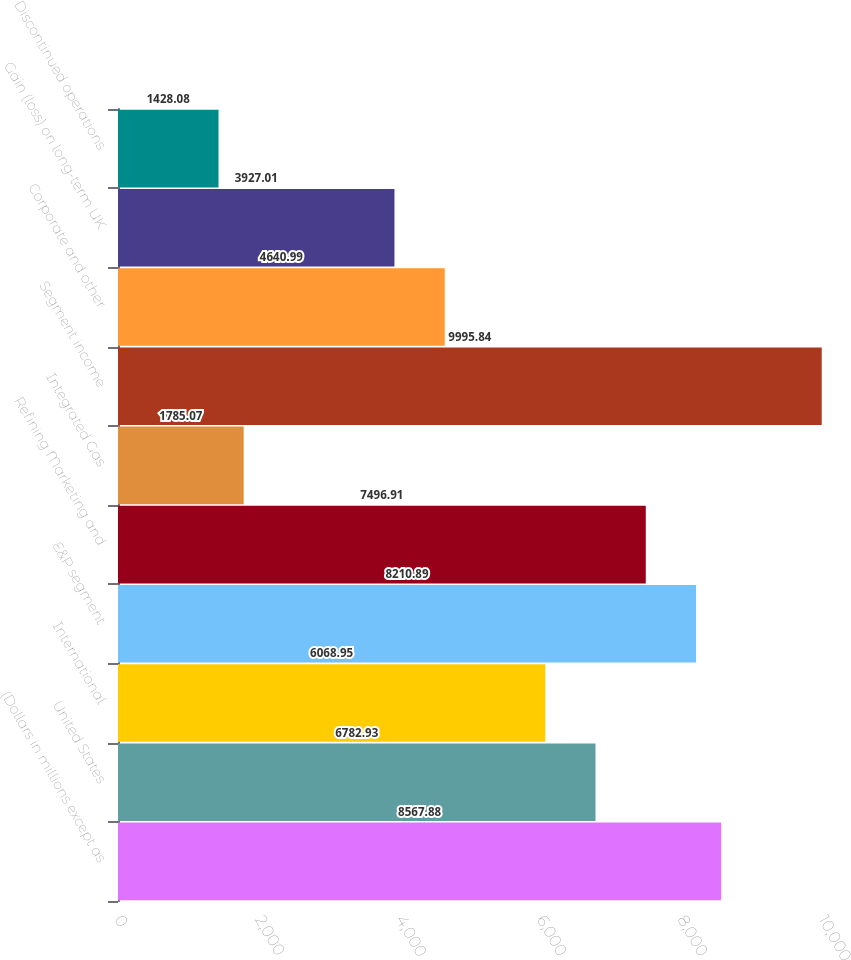Convert chart. <chart><loc_0><loc_0><loc_500><loc_500><bar_chart><fcel>(Dollars in millions except as<fcel>United States<fcel>International<fcel>E&P segment<fcel>Refining Marketing and<fcel>Integrated Gas<fcel>Segment income<fcel>Corporate and other<fcel>Gain (loss) on long-term UK<fcel>Discontinued operations<nl><fcel>8567.88<fcel>6782.93<fcel>6068.95<fcel>8210.89<fcel>7496.91<fcel>1785.07<fcel>9995.84<fcel>4640.99<fcel>3927.01<fcel>1428.08<nl></chart> 